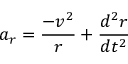<formula> <loc_0><loc_0><loc_500><loc_500>a _ { r } = { \frac { - v ^ { 2 } } { r } } + { \frac { d ^ { 2 } r } { d t ^ { 2 } } }</formula> 